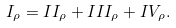<formula> <loc_0><loc_0><loc_500><loc_500>I _ { \rho } = I I _ { \rho } + I I I _ { \rho } + I V _ { \rho } .</formula> 